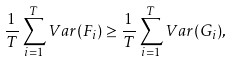<formula> <loc_0><loc_0><loc_500><loc_500>\frac { 1 } { T } \sum _ { i = 1 } ^ { T } V a r ( F _ { i } ) \geq \frac { 1 } { T } \sum _ { i = 1 } ^ { T } V a r ( G _ { i } ) ,</formula> 